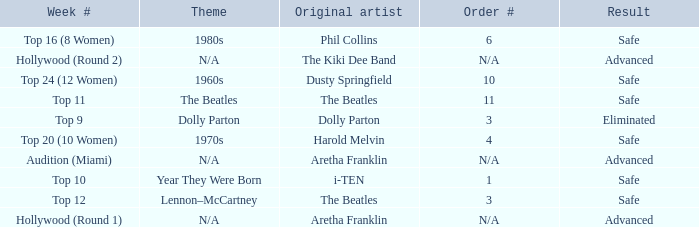What is the order number that has Aretha Franklin as the original artist? N/A, N/A. Would you be able to parse every entry in this table? {'header': ['Week #', 'Theme', 'Original artist', 'Order #', 'Result'], 'rows': [['Top 16 (8 Women)', '1980s', 'Phil Collins', '6', 'Safe'], ['Hollywood (Round 2)', 'N/A', 'The Kiki Dee Band', 'N/A', 'Advanced'], ['Top 24 (12 Women)', '1960s', 'Dusty Springfield', '10', 'Safe'], ['Top 11', 'The Beatles', 'The Beatles', '11', 'Safe'], ['Top 9', 'Dolly Parton', 'Dolly Parton', '3', 'Eliminated'], ['Top 20 (10 Women)', '1970s', 'Harold Melvin', '4', 'Safe'], ['Audition (Miami)', 'N/A', 'Aretha Franklin', 'N/A', 'Advanced'], ['Top 10', 'Year They Were Born', 'i-TEN', '1', 'Safe'], ['Top 12', 'Lennon–McCartney', 'The Beatles', '3', 'Safe'], ['Hollywood (Round 1)', 'N/A', 'Aretha Franklin', 'N/A', 'Advanced']]} 